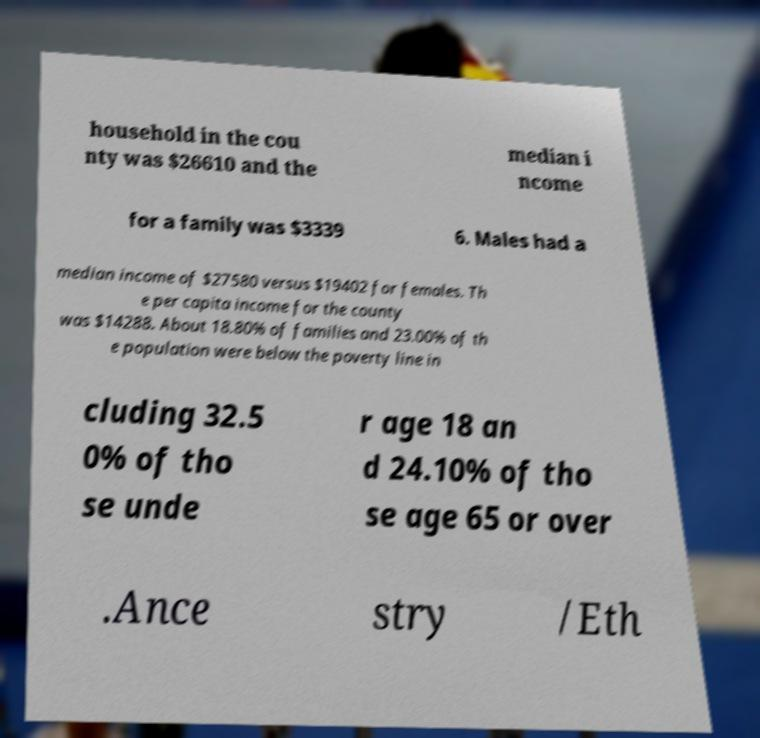For documentation purposes, I need the text within this image transcribed. Could you provide that? household in the cou nty was $26610 and the median i ncome for a family was $3339 6. Males had a median income of $27580 versus $19402 for females. Th e per capita income for the county was $14288. About 18.80% of families and 23.00% of th e population were below the poverty line in cluding 32.5 0% of tho se unde r age 18 an d 24.10% of tho se age 65 or over .Ance stry /Eth 